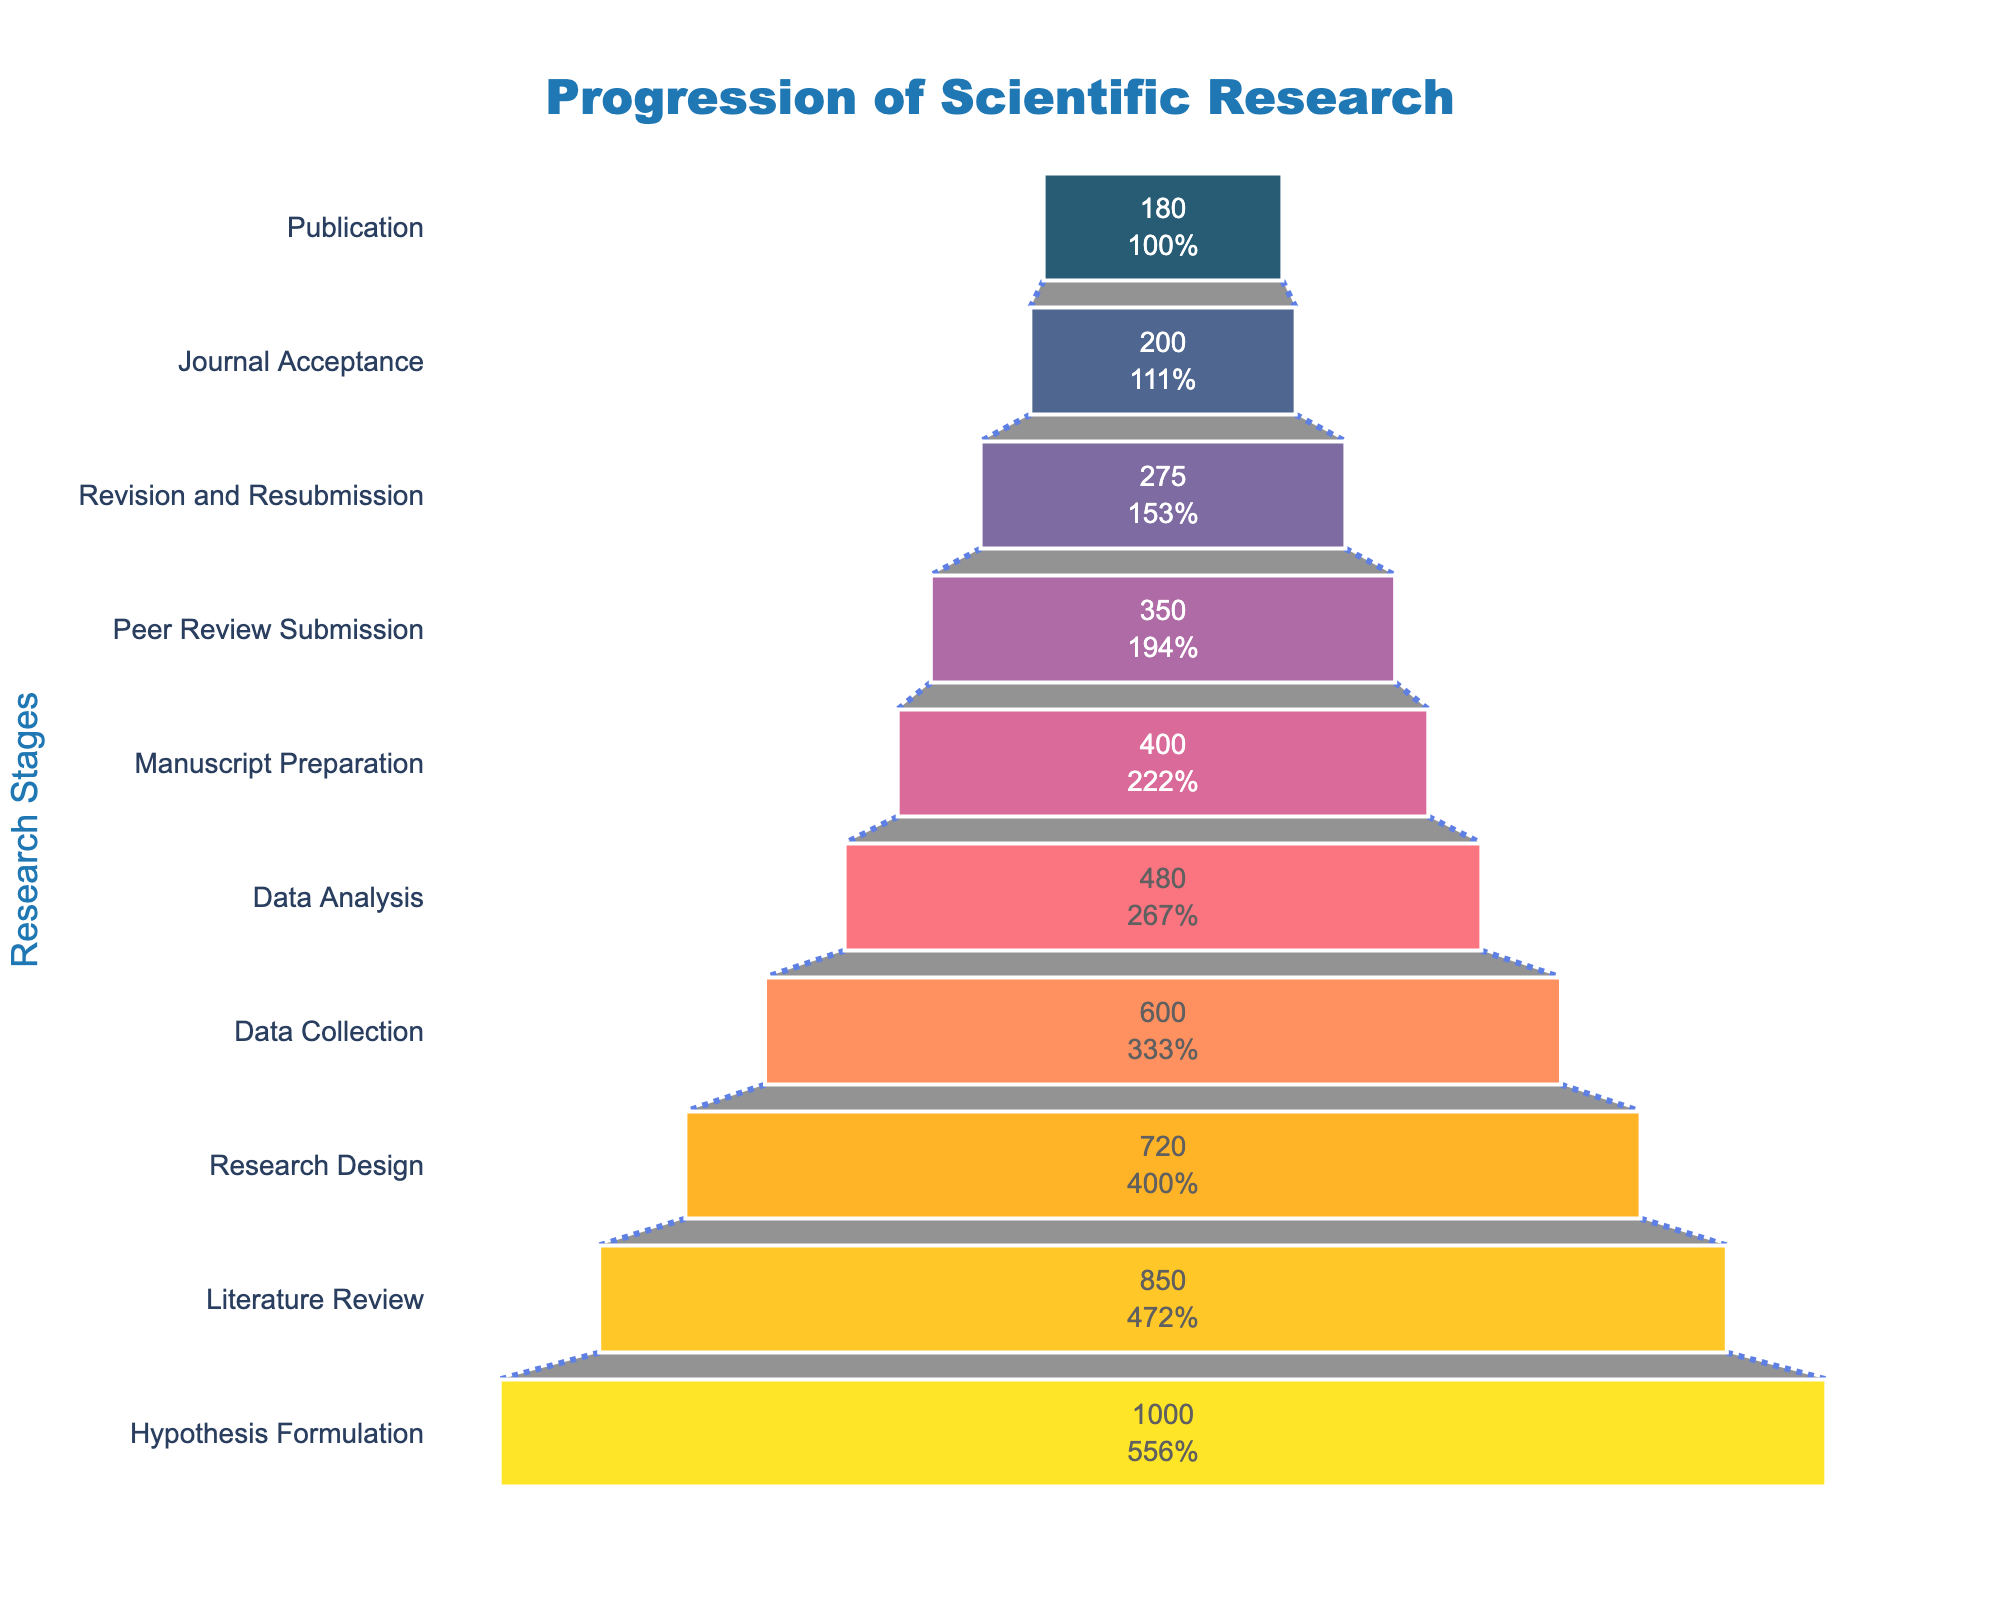What is the title of the Funnel Chart? The title is located at the top of the chart and reads "Progression of Scientific Research".
Answer: Progression of Scientific Research What are the stages listed in the Funnel Chart? The stages in the funnel chart are listed on the y-axis in descending order from top to bottom. They are: Publication, Journal Acceptance, Revision and Resubmission, Peer Review Submission, Manuscript Preparation, Data Analysis, Data Collection, Research Design, Literature Review, Hypothesis Formulation.
Answer: Publication, Journal Acceptance, Revision and Resubmission, Peer Review Submission, Manuscript Preparation, Data Analysis, Data Collection, Research Design, Literature Review, Hypothesis Formulation How many projects reach the 'Data Analysis' stage? The x-axis represents the number of projects, and the label inside the bar for 'Data Analysis' shows 480 projects reach this stage.
Answer: 480 Which stage experiences the greatest drop in number of projects from the previous stage? To find the greatest drop, subtract the number of projects in each stage from the previous stage and identify the maximum drop. The number of projects decreases from 600 in Data Collection to 480 in Data Analysis, which is a drop of 120, the largest drop among all transitions.
Answer: Data Collection to Data Analysis What percentage of the initial 1000 projects reach the 'Journal Acceptance' stage? To calculate the percentage, use the value at ‘Journal Acceptance’ (200) and divide it by the initial number (1000): (200/1000) × 100 = 20%.
Answer: 20% How many total stages are depicted in the funnel chart? Count the number of unique stages listed on the y-axis. There are 10 stages depicted in the chart.
Answer: 10 Compare the number of projects in 'Literature Review' and 'Manuscript Preparation'. Which has more projects? Refer to the labels for these stages. Literature Review has 850 projects and Manuscript Preparation has 400. So, Literature Review has more projects.
Answer: Literature Review What is the decrease in the number of projects from 'Hypothesis Formulation' to 'Publication'? Subtract the number of projects at 'Publication' (180) from those at 'Hypothesis Formulation' (1000): 1000 - 180 = 820.
Answer: 820 If you combine the 'Peer Review Submission' and 'Revision and Resubmission' stages, how many projects are there together in these stages? Add the number of projects in 'Peer Review Submission' (350) and 'Revision and Resubmission' (275): 350 + 275 = 625.
Answer: 625 